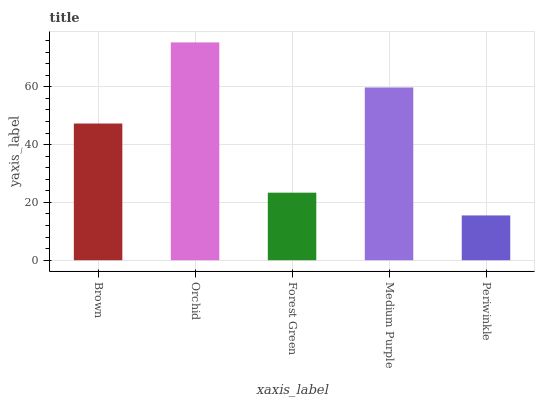Is Periwinkle the minimum?
Answer yes or no. Yes. Is Orchid the maximum?
Answer yes or no. Yes. Is Forest Green the minimum?
Answer yes or no. No. Is Forest Green the maximum?
Answer yes or no. No. Is Orchid greater than Forest Green?
Answer yes or no. Yes. Is Forest Green less than Orchid?
Answer yes or no. Yes. Is Forest Green greater than Orchid?
Answer yes or no. No. Is Orchid less than Forest Green?
Answer yes or no. No. Is Brown the high median?
Answer yes or no. Yes. Is Brown the low median?
Answer yes or no. Yes. Is Periwinkle the high median?
Answer yes or no. No. Is Periwinkle the low median?
Answer yes or no. No. 